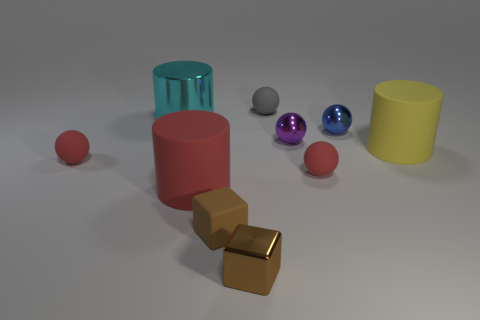Subtract 2 balls. How many balls are left? 3 Subtract all tiny blue spheres. How many spheres are left? 4 Subtract all green balls. Subtract all purple cylinders. How many balls are left? 5 Subtract all blocks. How many objects are left? 8 Subtract 0 brown spheres. How many objects are left? 10 Subtract all tiny brown rubber balls. Subtract all red cylinders. How many objects are left? 9 Add 3 tiny cubes. How many tiny cubes are left? 5 Add 6 tiny purple balls. How many tiny purple balls exist? 7 